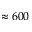Convert formula to latex. <formula><loc_0><loc_0><loc_500><loc_500>\approx 6 0 0</formula> 